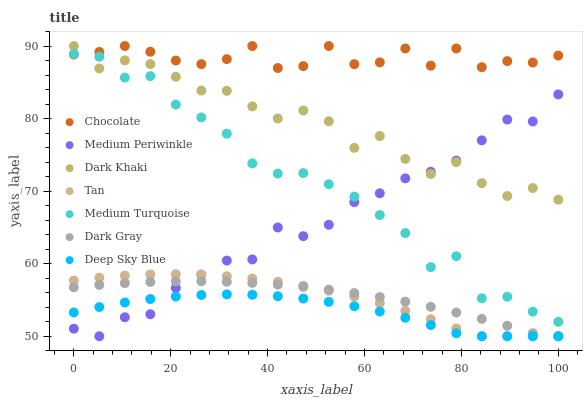Does Deep Sky Blue have the minimum area under the curve?
Answer yes or no. Yes. Does Chocolate have the maximum area under the curve?
Answer yes or no. Yes. Does Medium Periwinkle have the minimum area under the curve?
Answer yes or no. No. Does Medium Periwinkle have the maximum area under the curve?
Answer yes or no. No. Is Dark Gray the smoothest?
Answer yes or no. Yes. Is Medium Turquoise the roughest?
Answer yes or no. Yes. Is Deep Sky Blue the smoothest?
Answer yes or no. No. Is Deep Sky Blue the roughest?
Answer yes or no. No. Does Dark Gray have the lowest value?
Answer yes or no. Yes. Does Chocolate have the lowest value?
Answer yes or no. No. Does Dark Khaki have the highest value?
Answer yes or no. Yes. Does Medium Periwinkle have the highest value?
Answer yes or no. No. Is Medium Periwinkle less than Chocolate?
Answer yes or no. Yes. Is Chocolate greater than Deep Sky Blue?
Answer yes or no. Yes. Does Tan intersect Dark Gray?
Answer yes or no. Yes. Is Tan less than Dark Gray?
Answer yes or no. No. Is Tan greater than Dark Gray?
Answer yes or no. No. Does Medium Periwinkle intersect Chocolate?
Answer yes or no. No. 